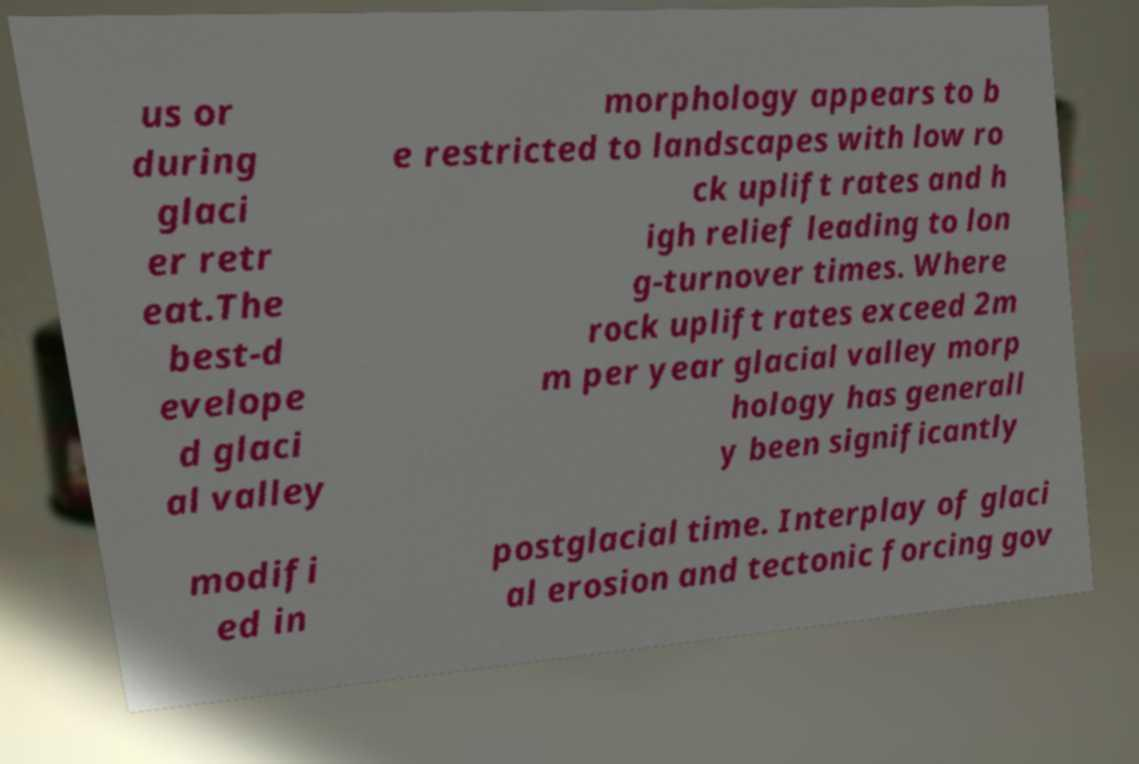Could you extract and type out the text from this image? us or during glaci er retr eat.The best-d evelope d glaci al valley morphology appears to b e restricted to landscapes with low ro ck uplift rates and h igh relief leading to lon g-turnover times. Where rock uplift rates exceed 2m m per year glacial valley morp hology has generall y been significantly modifi ed in postglacial time. Interplay of glaci al erosion and tectonic forcing gov 